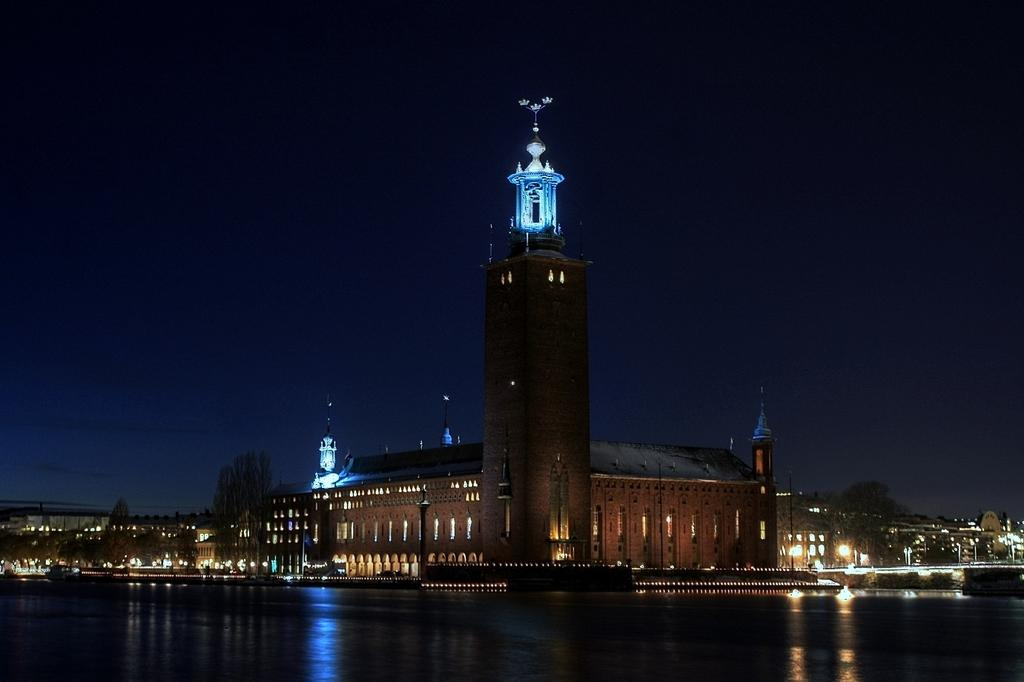What is in the foreground of the image? There is a water body in the foreground of the image. What can be seen in the center of the image? There are buildings, lights, and trees in the center of the image. What type of jam is being spread on the trees in the image? There is no jam or spreading activity present in the image; it features a water body, buildings, lights, and trees. 